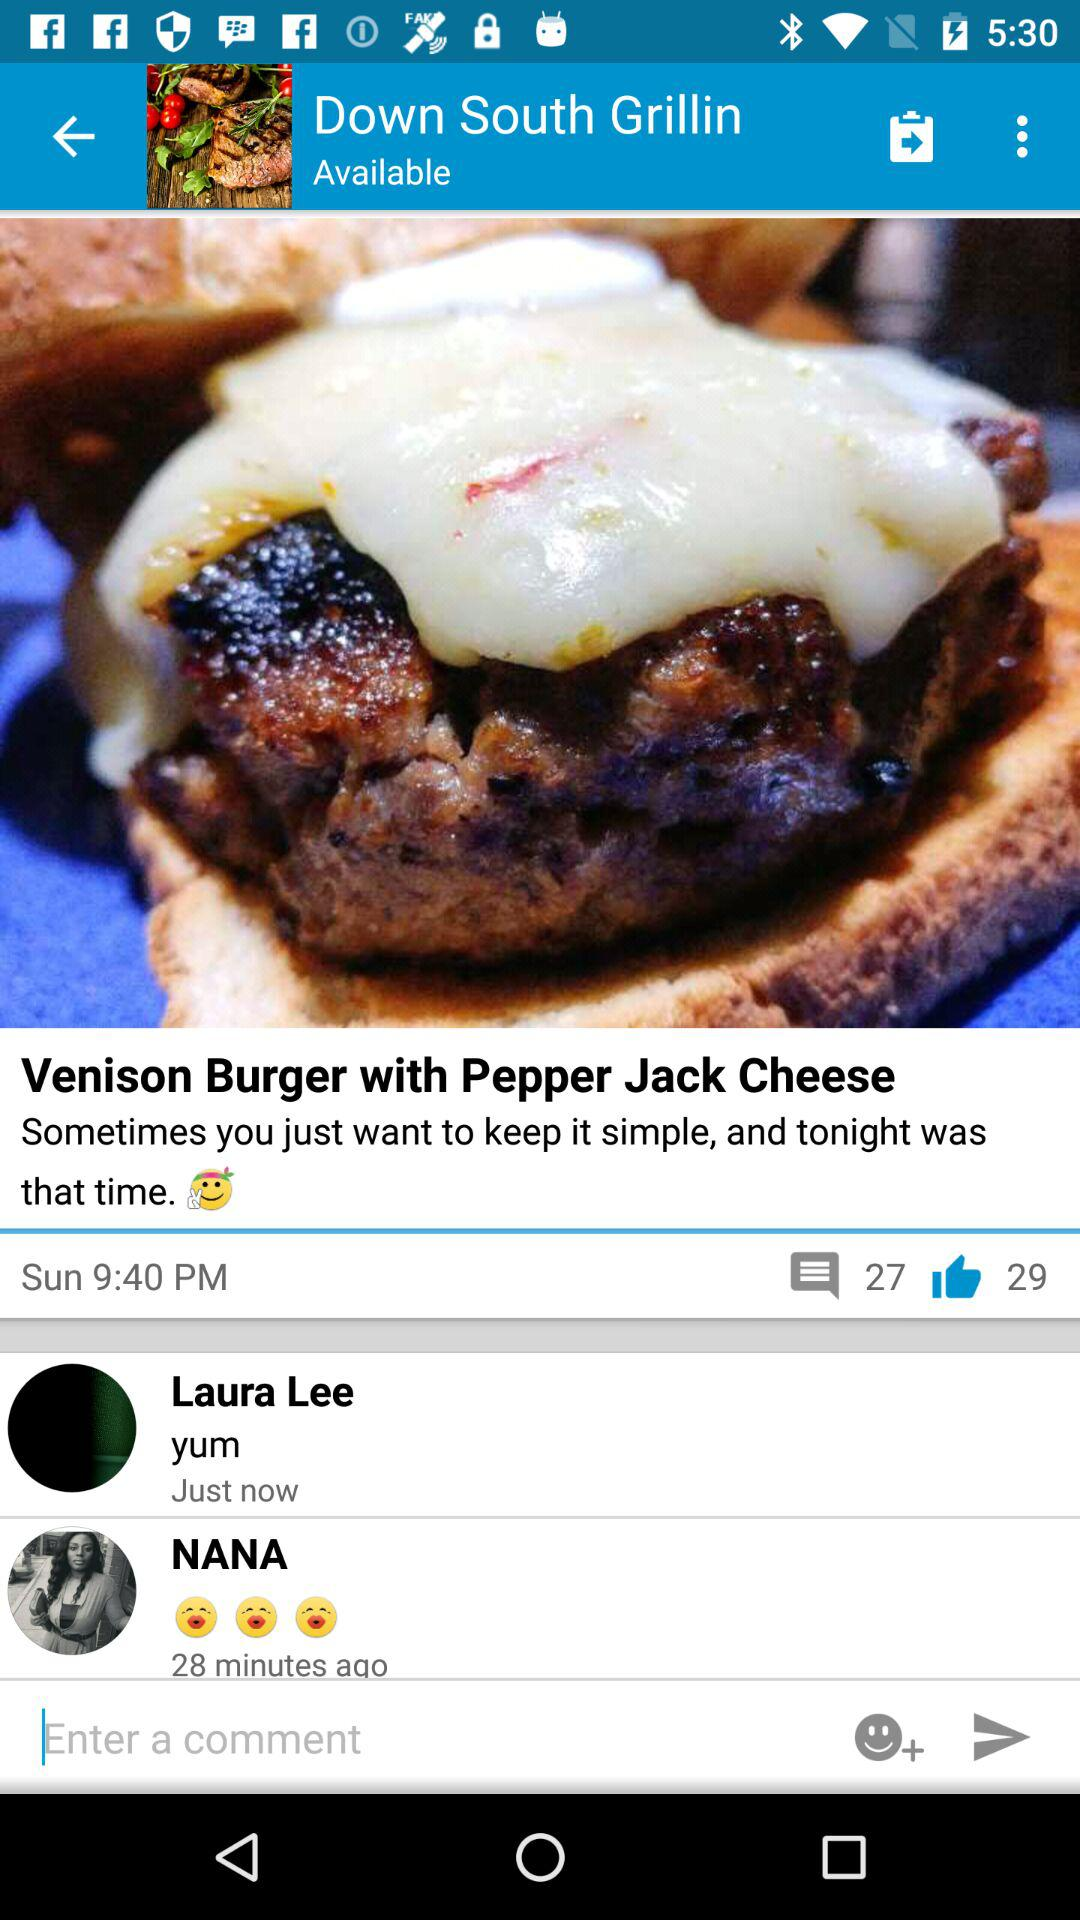How many thumbs up does this post have?
Answer the question using a single word or phrase. 29 